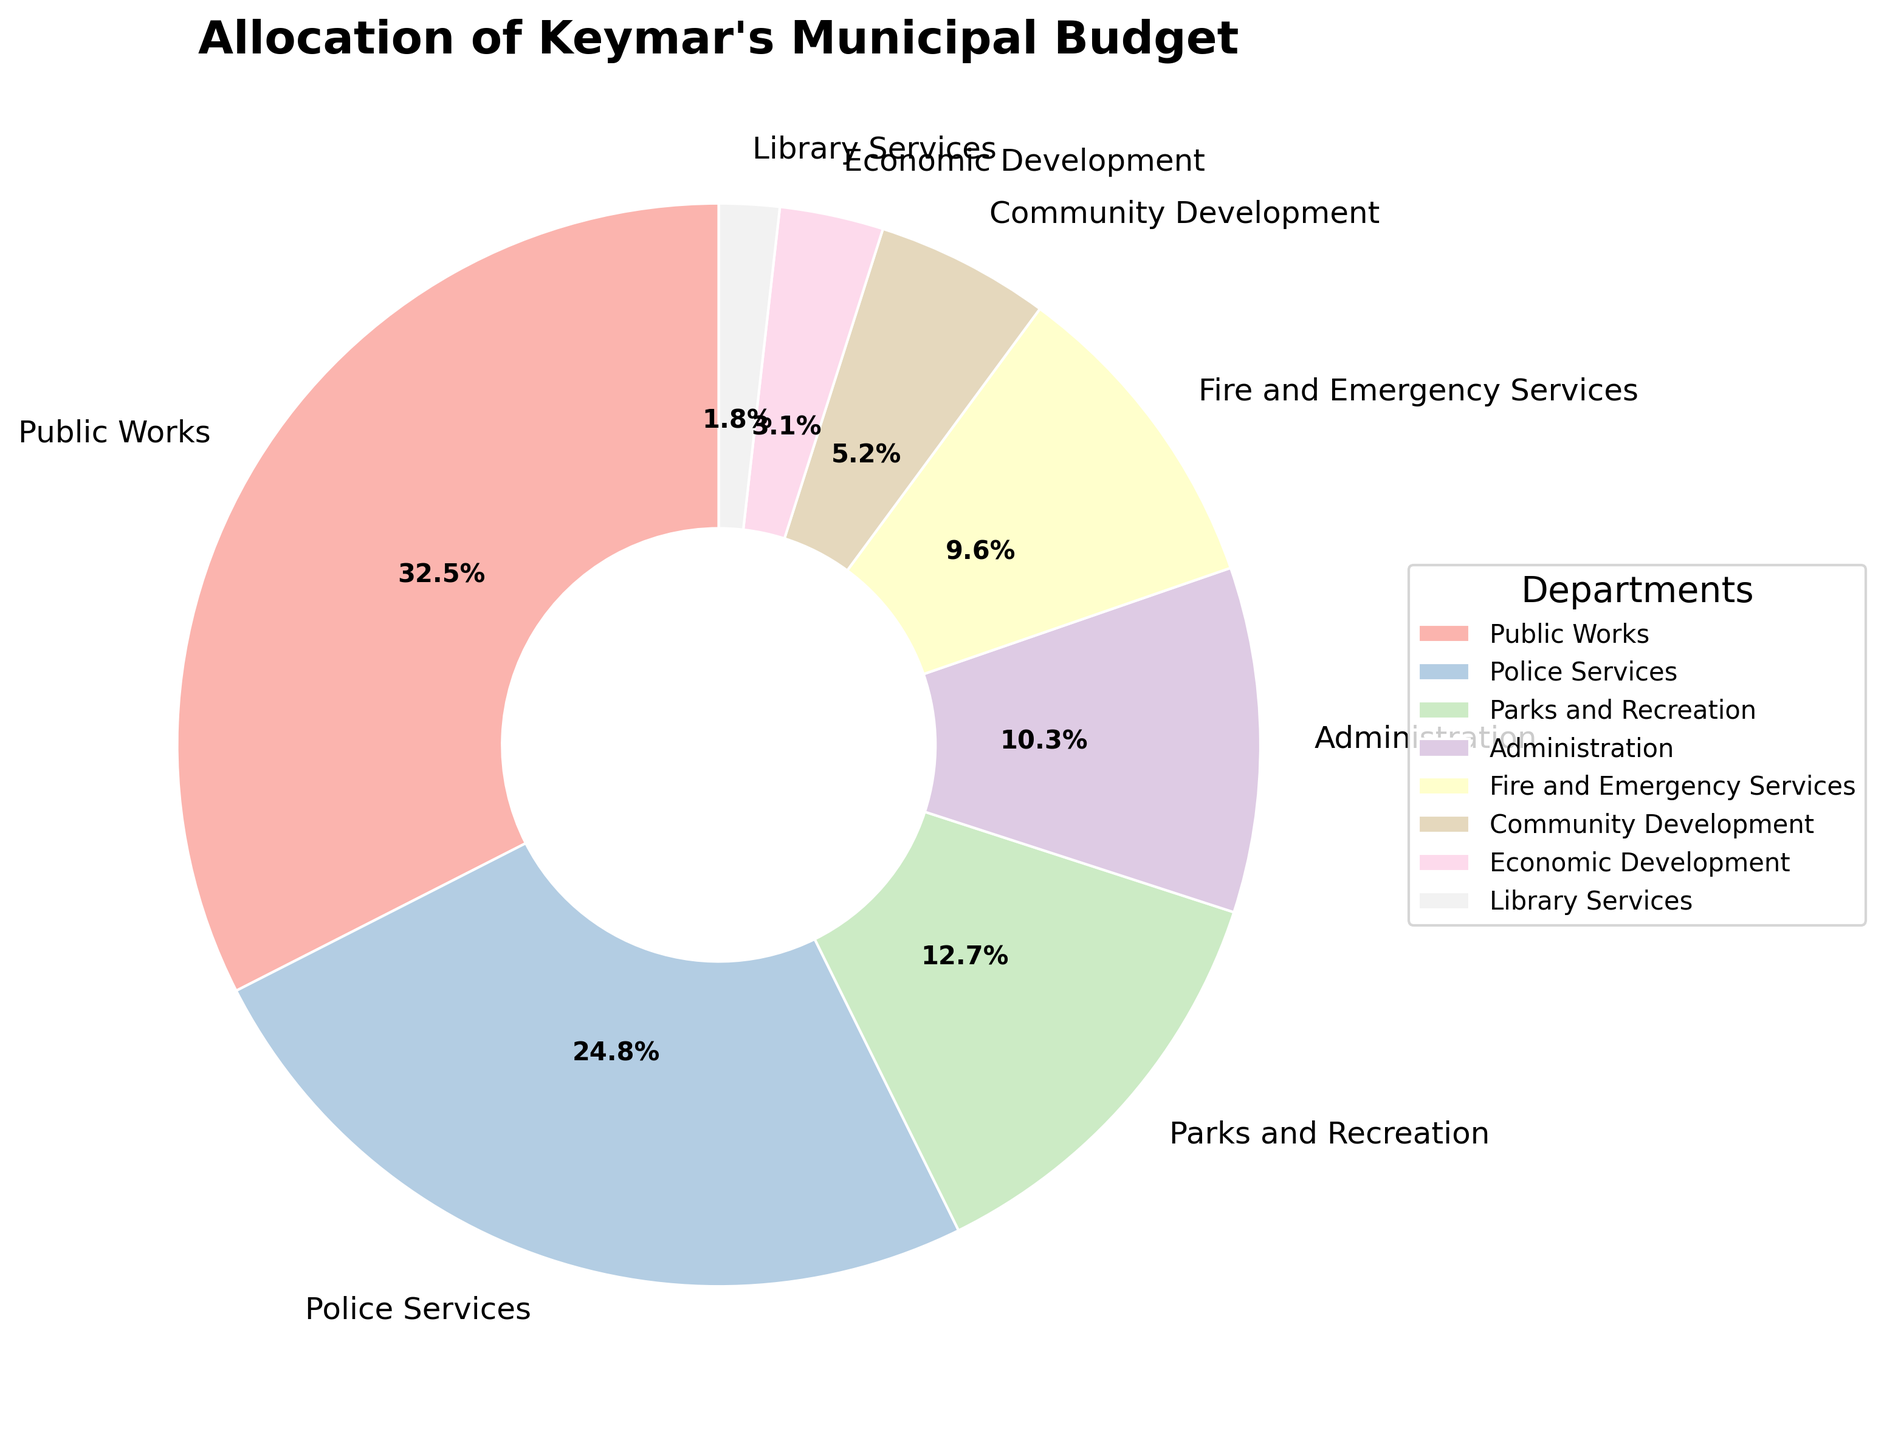What is the largest share of the budget allocated to a single department? The largest share is represented by the department that has the highest percentage in the pie chart. By inspecting the chart, we see that Public Works has the highest allocation.
Answer: 32.5% Which department has a higher budget allocation: Police Services or Parks and Recreation? To compare, we find the percentages of both departments in the pie chart. Police Services has 24.8%, and Parks and Recreation has 12.7%. So, Police Services has a higher budget allocation.
Answer: Police Services What is the combined budget allocation for Administration and Fire and Emergency Services? We add the budget allocations for Administration (10.3%) and Fire and Emergency Services (9.6%) as shown in the pie chart: 10.3% + 9.6% = 19.9%.
Answer: 19.9% Does Community Development have a higher budget allocation than Economic Development? By comparing the percentages for Community Development (5.2%) and Economic Development (3.1%) in the pie chart, we see that Community Development has a higher allocation.
Answer: Yes What is the total budget allocation for Police Services, Parks and Recreation, and Library Services combined? We add the budget allocations for the three departments: Police Services (24.8%), Parks and Recreation (12.7%), and Library Services (1.8%). 24.8% + 12.7% + 1.8% = 39.3%.
Answer: 39.3% Which department has the smallest budget allocation? The department with the smallest slice in the pie chart represents the smallest budget allocation. According to the chart, Library Services has the smallest allocation at 1.8%.
Answer: Library Services How much more is allocated to Public Works compared to Administration? To find the difference, we subtract Administration's allocation (10.3%) from Public Works' allocation (32.5%): 32.5% - 10.3% = 22.2%.
Answer: 22.2% What fraction of the total budget is allocated to Fire and Emergency Services and Community Development combined? We find the sum of their allocations: Fire and Emergency Services (9.6%) + Community Development (5.2%) = 14.8%. This is 14.8/100 as a fraction of the total budget.
Answer: 14.8/100 Are there more funds allocated to Economic Development than Library Services? By comparing their percentages in the pie chart, Economic Development has 3.1% and Library Services has 1.8%—Economic Development has a higher allocation.
Answer: Yes 